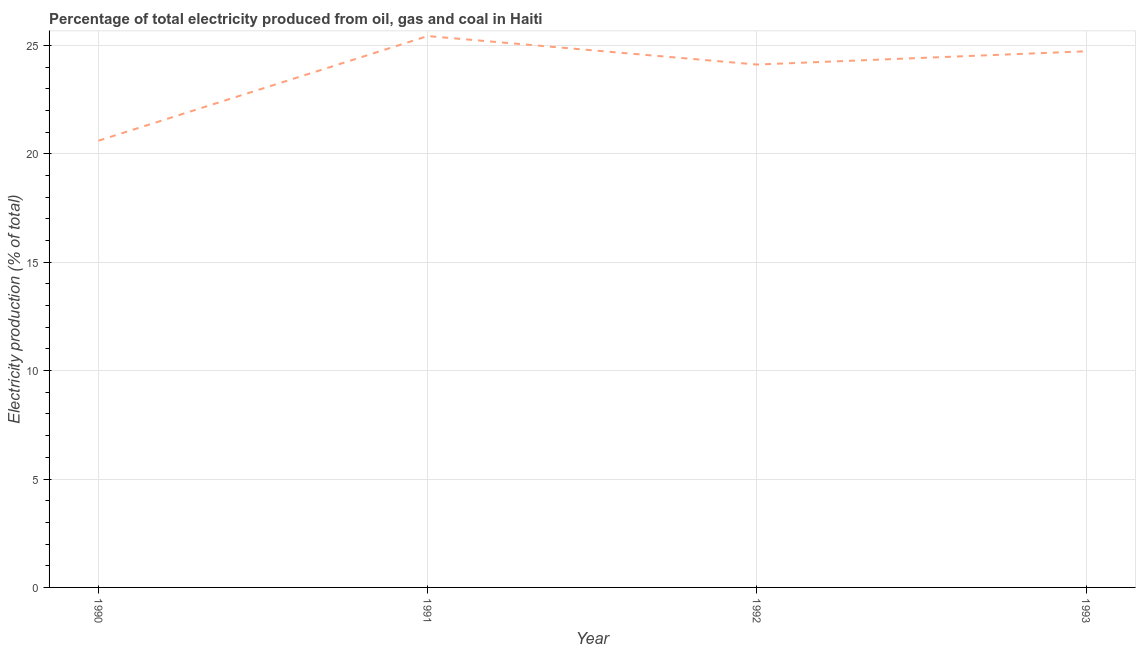What is the electricity production in 1993?
Give a very brief answer. 24.73. Across all years, what is the maximum electricity production?
Make the answer very short. 25.43. Across all years, what is the minimum electricity production?
Provide a short and direct response. 20.6. What is the sum of the electricity production?
Give a very brief answer. 94.87. What is the difference between the electricity production in 1990 and 1993?
Keep it short and to the point. -4.12. What is the average electricity production per year?
Keep it short and to the point. 23.72. What is the median electricity production?
Keep it short and to the point. 24.42. What is the ratio of the electricity production in 1990 to that in 1993?
Offer a very short reply. 0.83. What is the difference between the highest and the second highest electricity production?
Provide a short and direct response. 0.7. Is the sum of the electricity production in 1990 and 1991 greater than the maximum electricity production across all years?
Ensure brevity in your answer.  Yes. What is the difference between the highest and the lowest electricity production?
Keep it short and to the point. 4.82. In how many years, is the electricity production greater than the average electricity production taken over all years?
Your response must be concise. 3. Does the electricity production monotonically increase over the years?
Give a very brief answer. No. How many years are there in the graph?
Provide a succinct answer. 4. What is the difference between two consecutive major ticks on the Y-axis?
Your answer should be compact. 5. Are the values on the major ticks of Y-axis written in scientific E-notation?
Make the answer very short. No. Does the graph contain any zero values?
Your response must be concise. No. Does the graph contain grids?
Provide a succinct answer. Yes. What is the title of the graph?
Make the answer very short. Percentage of total electricity produced from oil, gas and coal in Haiti. What is the label or title of the X-axis?
Offer a terse response. Year. What is the label or title of the Y-axis?
Offer a terse response. Electricity production (% of total). What is the Electricity production (% of total) in 1990?
Provide a succinct answer. 20.6. What is the Electricity production (% of total) of 1991?
Offer a very short reply. 25.43. What is the Electricity production (% of total) in 1992?
Give a very brief answer. 24.11. What is the Electricity production (% of total) in 1993?
Make the answer very short. 24.73. What is the difference between the Electricity production (% of total) in 1990 and 1991?
Offer a very short reply. -4.82. What is the difference between the Electricity production (% of total) in 1990 and 1992?
Offer a very short reply. -3.51. What is the difference between the Electricity production (% of total) in 1990 and 1993?
Provide a short and direct response. -4.12. What is the difference between the Electricity production (% of total) in 1991 and 1992?
Make the answer very short. 1.31. What is the difference between the Electricity production (% of total) in 1991 and 1993?
Provide a succinct answer. 0.7. What is the difference between the Electricity production (% of total) in 1992 and 1993?
Keep it short and to the point. -0.61. What is the ratio of the Electricity production (% of total) in 1990 to that in 1991?
Keep it short and to the point. 0.81. What is the ratio of the Electricity production (% of total) in 1990 to that in 1992?
Your response must be concise. 0.85. What is the ratio of the Electricity production (% of total) in 1990 to that in 1993?
Offer a terse response. 0.83. What is the ratio of the Electricity production (% of total) in 1991 to that in 1992?
Make the answer very short. 1.05. What is the ratio of the Electricity production (% of total) in 1991 to that in 1993?
Your answer should be very brief. 1.03. 